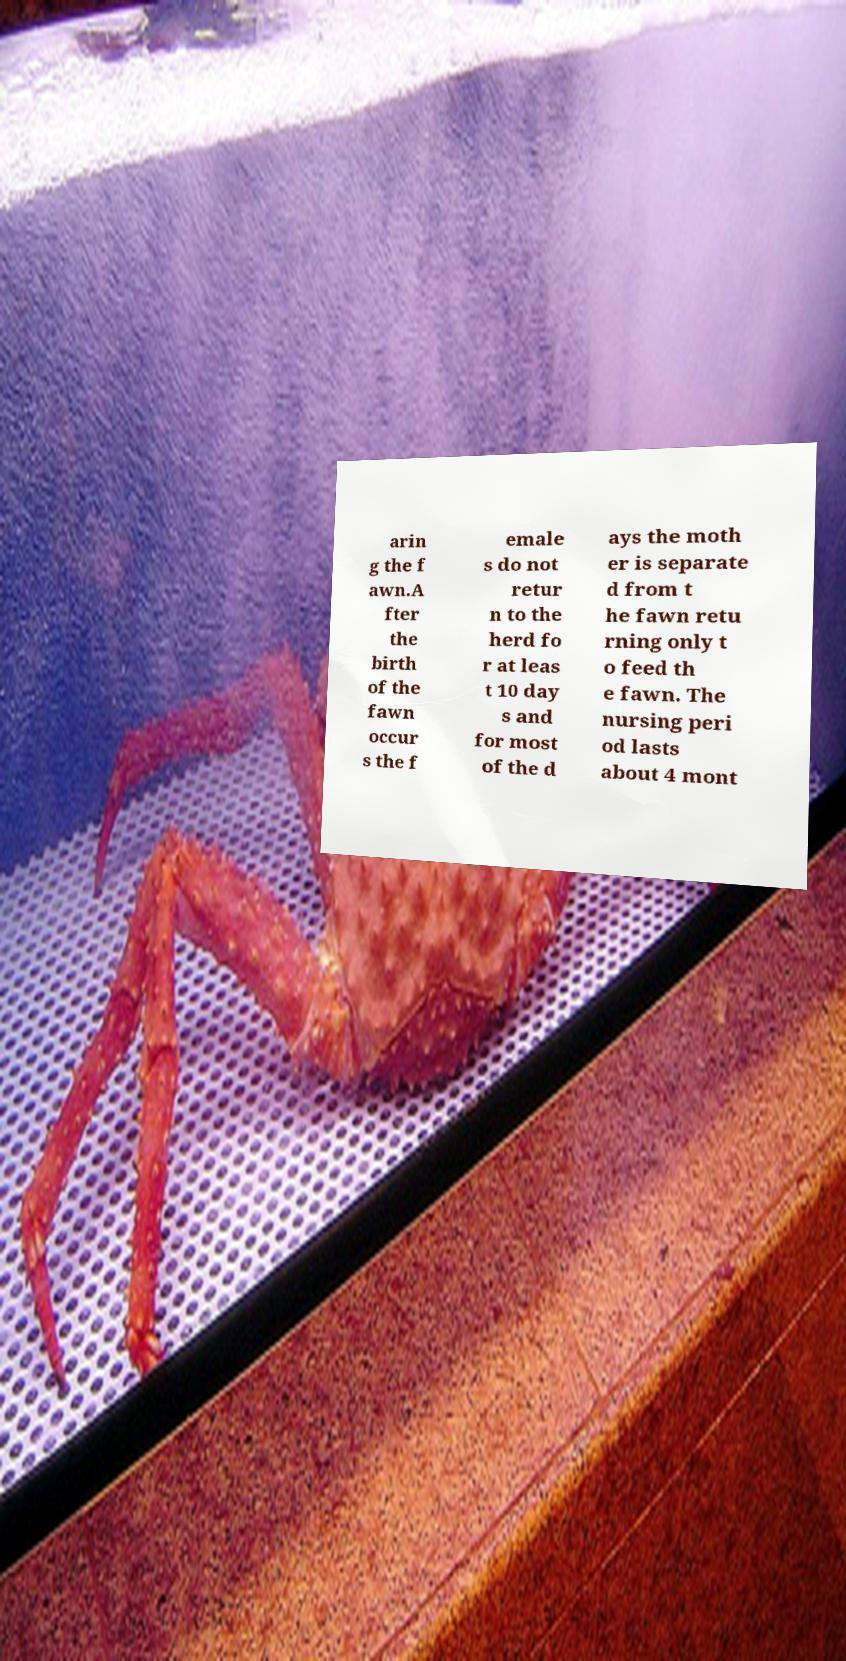Can you accurately transcribe the text from the provided image for me? arin g the f awn.A fter the birth of the fawn occur s the f emale s do not retur n to the herd fo r at leas t 10 day s and for most of the d ays the moth er is separate d from t he fawn retu rning only t o feed th e fawn. The nursing peri od lasts about 4 mont 